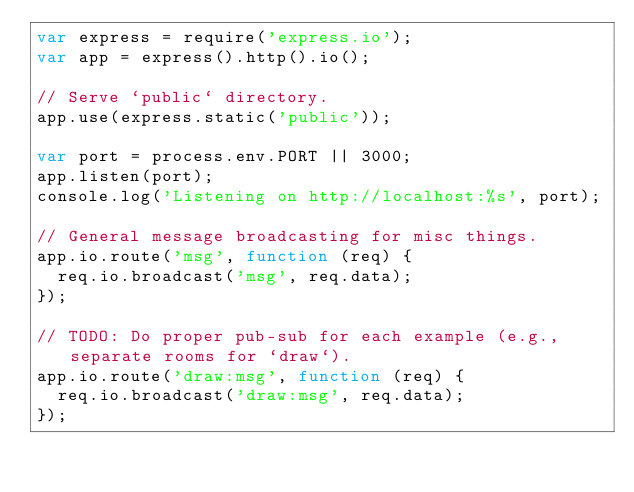<code> <loc_0><loc_0><loc_500><loc_500><_JavaScript_>var express = require('express.io');
var app = express().http().io();

// Serve `public` directory.
app.use(express.static('public'));

var port = process.env.PORT || 3000;
app.listen(port);
console.log('Listening on http://localhost:%s', port);

// General message broadcasting for misc things.
app.io.route('msg', function (req) {
  req.io.broadcast('msg', req.data);
});

// TODO: Do proper pub-sub for each example (e.g., separate rooms for `draw`).
app.io.route('draw:msg', function (req) {
  req.io.broadcast('draw:msg', req.data);
});
</code> 